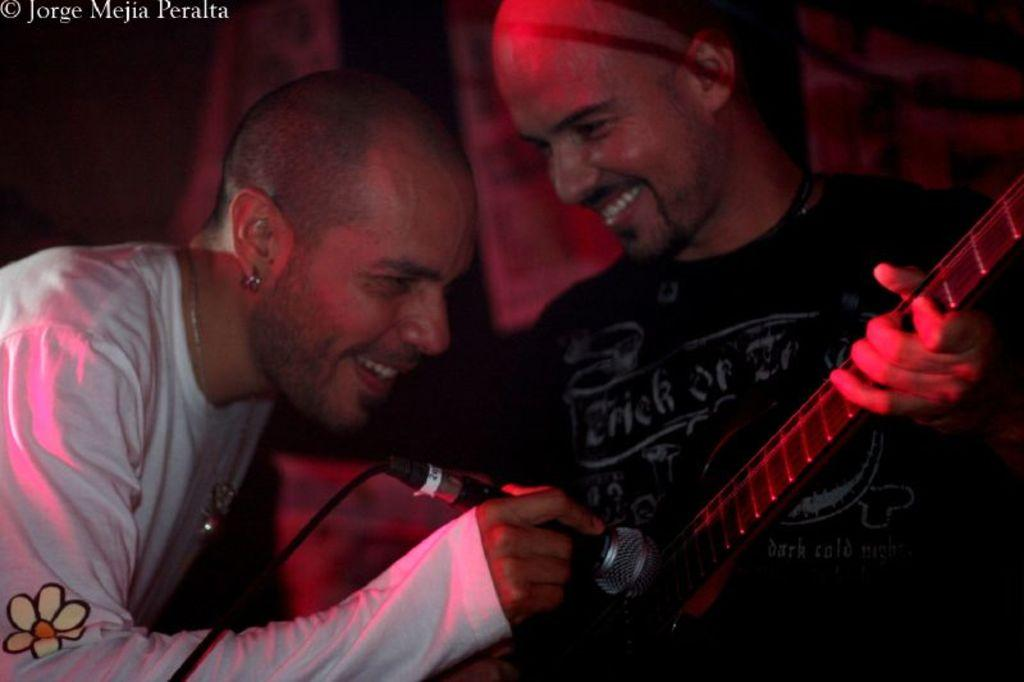How many people are in the image? There are two persons in the image. What are the people doing in the image? One person is playing guitar and wearing a black t-shirt, while the other person is holding a mic, smiling, and wearing a white t-shirt. What type of sea creature can be seen swimming near the person holding the mic? There is no sea creature present in the image; it features two people, one playing guitar and the other holding a mic. 